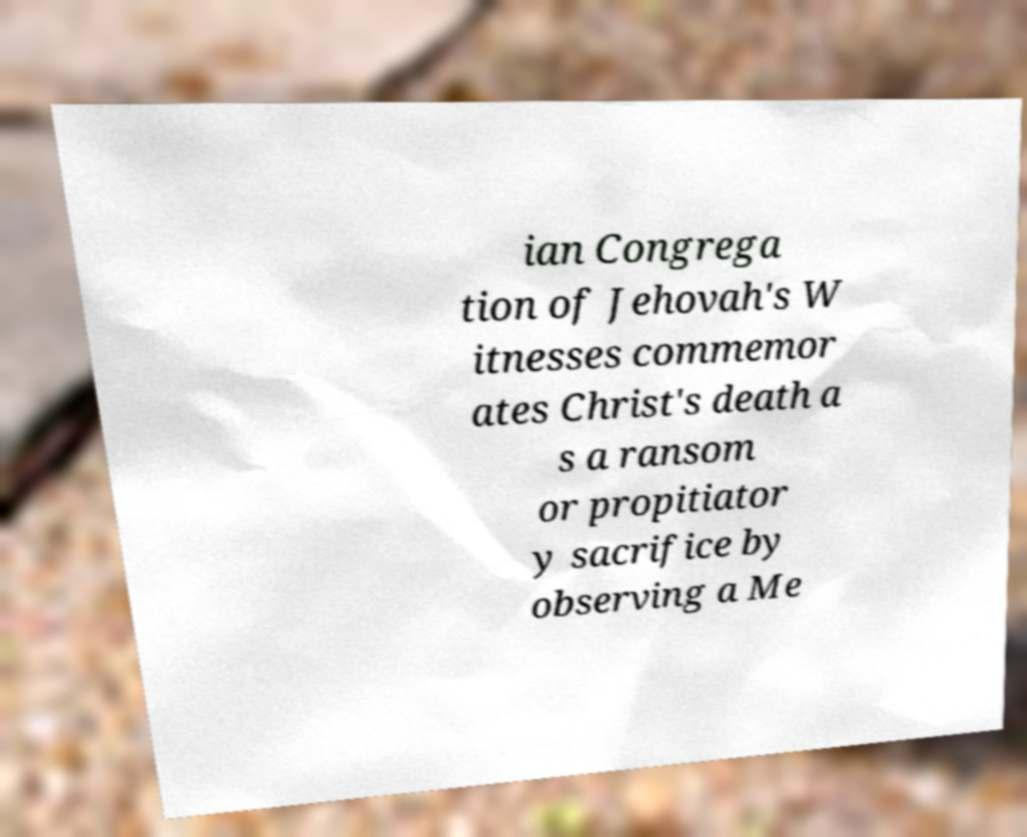Could you assist in decoding the text presented in this image and type it out clearly? ian Congrega tion of Jehovah's W itnesses commemor ates Christ's death a s a ransom or propitiator y sacrifice by observing a Me 